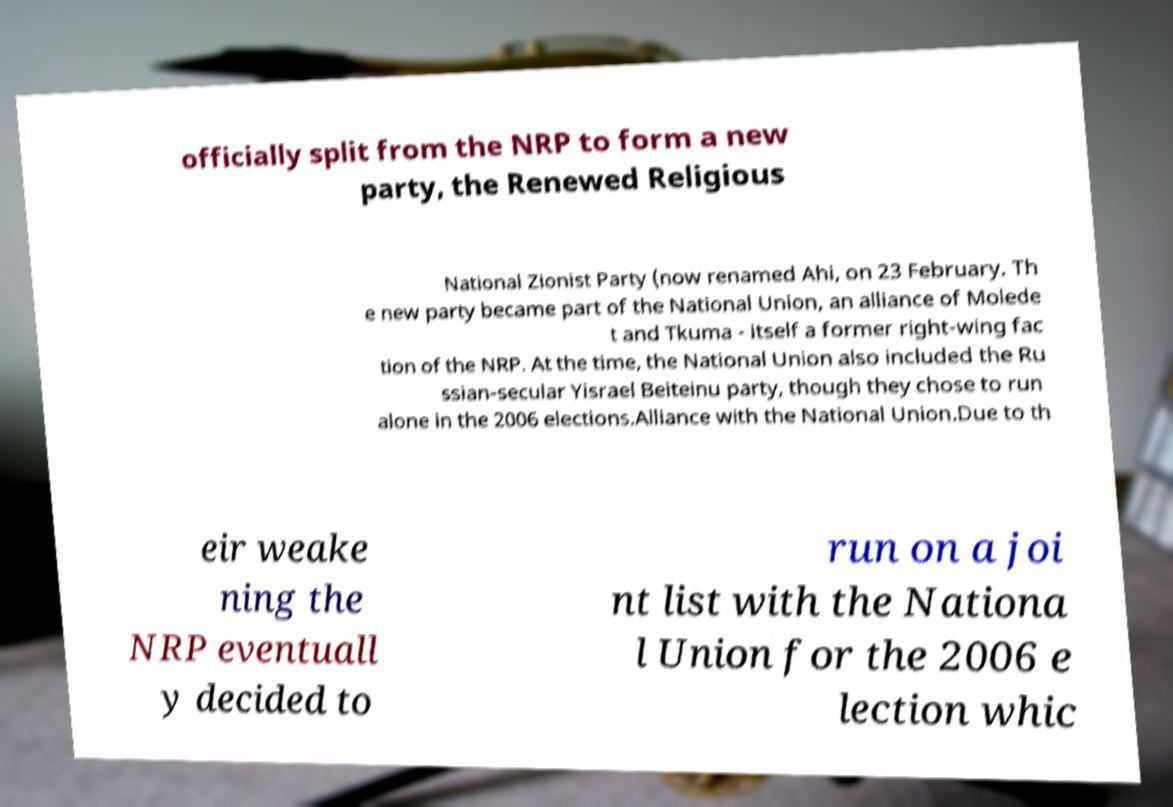Could you assist in decoding the text presented in this image and type it out clearly? officially split from the NRP to form a new party, the Renewed Religious National Zionist Party (now renamed Ahi, on 23 February. Th e new party became part of the National Union, an alliance of Molede t and Tkuma - itself a former right-wing fac tion of the NRP. At the time, the National Union also included the Ru ssian-secular Yisrael Beiteinu party, though they chose to run alone in the 2006 elections.Alliance with the National Union.Due to th eir weake ning the NRP eventuall y decided to run on a joi nt list with the Nationa l Union for the 2006 e lection whic 